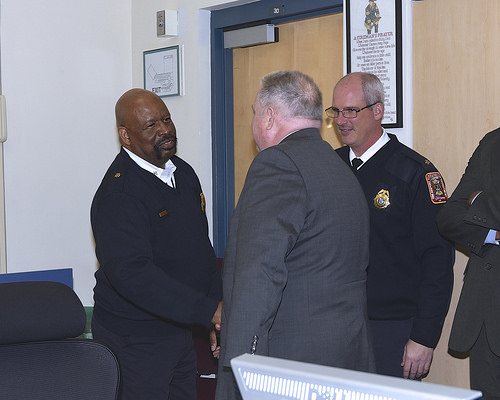<image>
Is the man to the right of the man? Yes. From this viewpoint, the man is positioned to the right side relative to the man. 